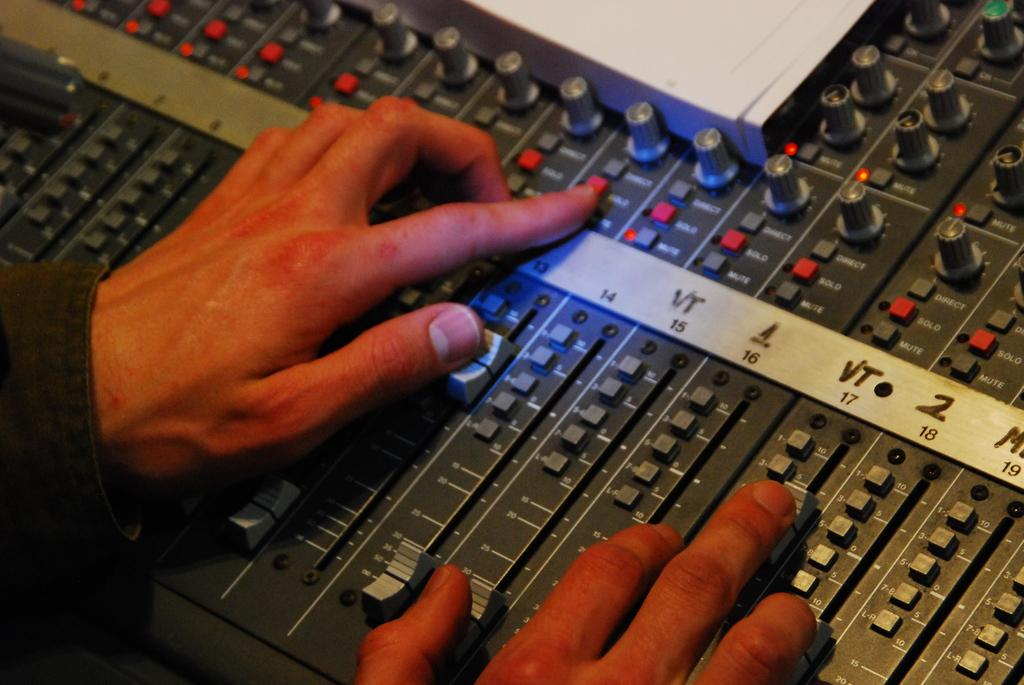<image>
Render a clear and concise summary of the photo. two hands working controls on a board that has a strip with numbers 14, 15, 16, 17, 18, 19 on it 